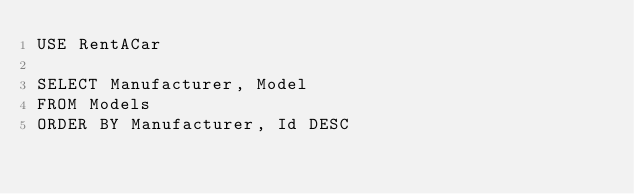<code> <loc_0><loc_0><loc_500><loc_500><_SQL_>USE RentACar

SELECT Manufacturer, Model
FROM Models
ORDER BY Manufacturer, Id DESC</code> 